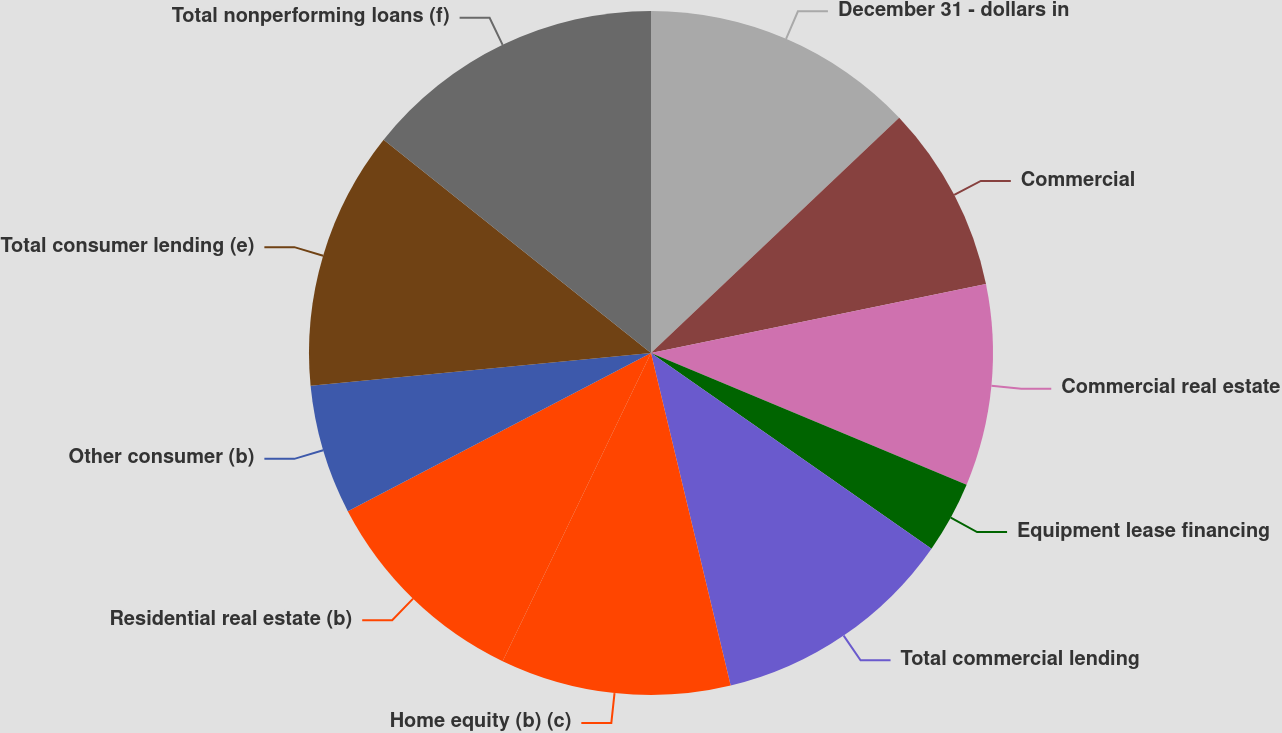<chart> <loc_0><loc_0><loc_500><loc_500><pie_chart><fcel>December 31 - dollars in<fcel>Commercial<fcel>Commercial real estate<fcel>Equipment lease financing<fcel>Total commercial lending<fcel>Home equity (b) (c)<fcel>Residential real estate (b)<fcel>Other consumer (b)<fcel>Total consumer lending (e)<fcel>Total nonperforming loans (f)<nl><fcel>12.92%<fcel>8.84%<fcel>9.52%<fcel>3.4%<fcel>11.56%<fcel>10.88%<fcel>10.2%<fcel>6.12%<fcel>12.24%<fcel>14.28%<nl></chart> 